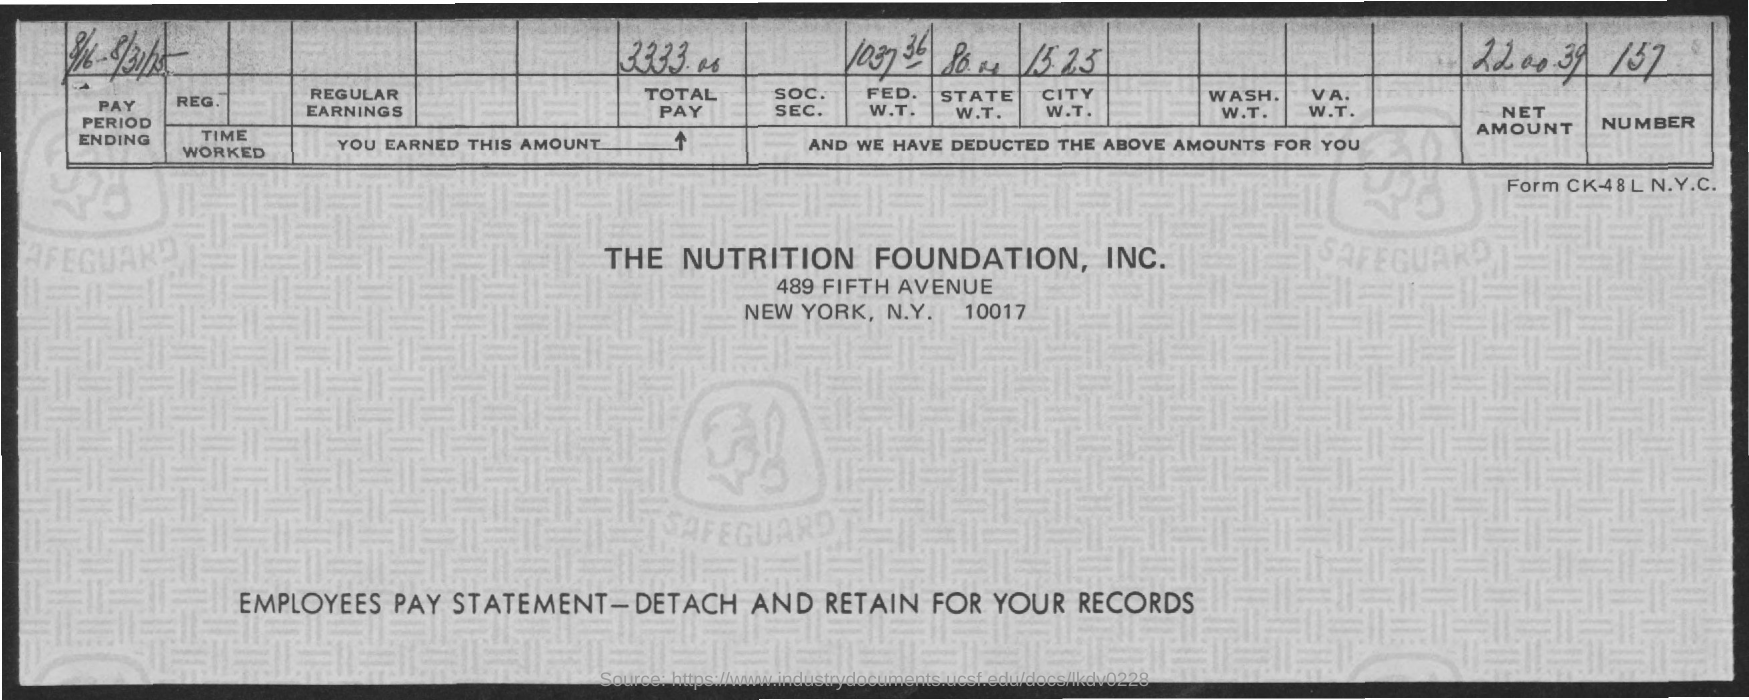What is the total amount pay of this Company?
Keep it short and to the point. 3333.00. What is the number given?
Your response must be concise. 157. 